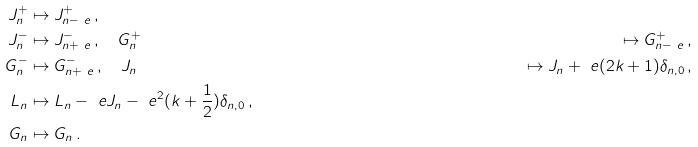<formula> <loc_0><loc_0><loc_500><loc_500>J ^ { + } _ { n } & \mapsto J ^ { + } _ { n - \ e } \, , \\ J ^ { - } _ { n } & \mapsto J ^ { - } _ { n + \ e } \, , \quad G ^ { + } _ { n } & \mapsto G ^ { + } _ { n - \ e } \, , \\ G ^ { - } _ { n } & \mapsto G ^ { - } _ { n + \ e } \, , \quad J _ { n } & \mapsto J _ { n } + \ e ( 2 k + 1 ) \delta _ { n , 0 } \, , \\ L _ { n } & \mapsto L _ { n } - \ e J _ { n } - \ e ^ { 2 } ( k + \frac { 1 } { 2 } ) \delta _ { n , 0 } \, , \\ G _ { n } & \mapsto G _ { n } \, .</formula> 